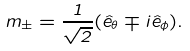Convert formula to latex. <formula><loc_0><loc_0><loc_500><loc_500>m _ { \pm } = \frac { 1 } { \sqrt { 2 } } ( \hat { e } _ { \theta } \mp i \hat { e } _ { \phi } ) .</formula> 